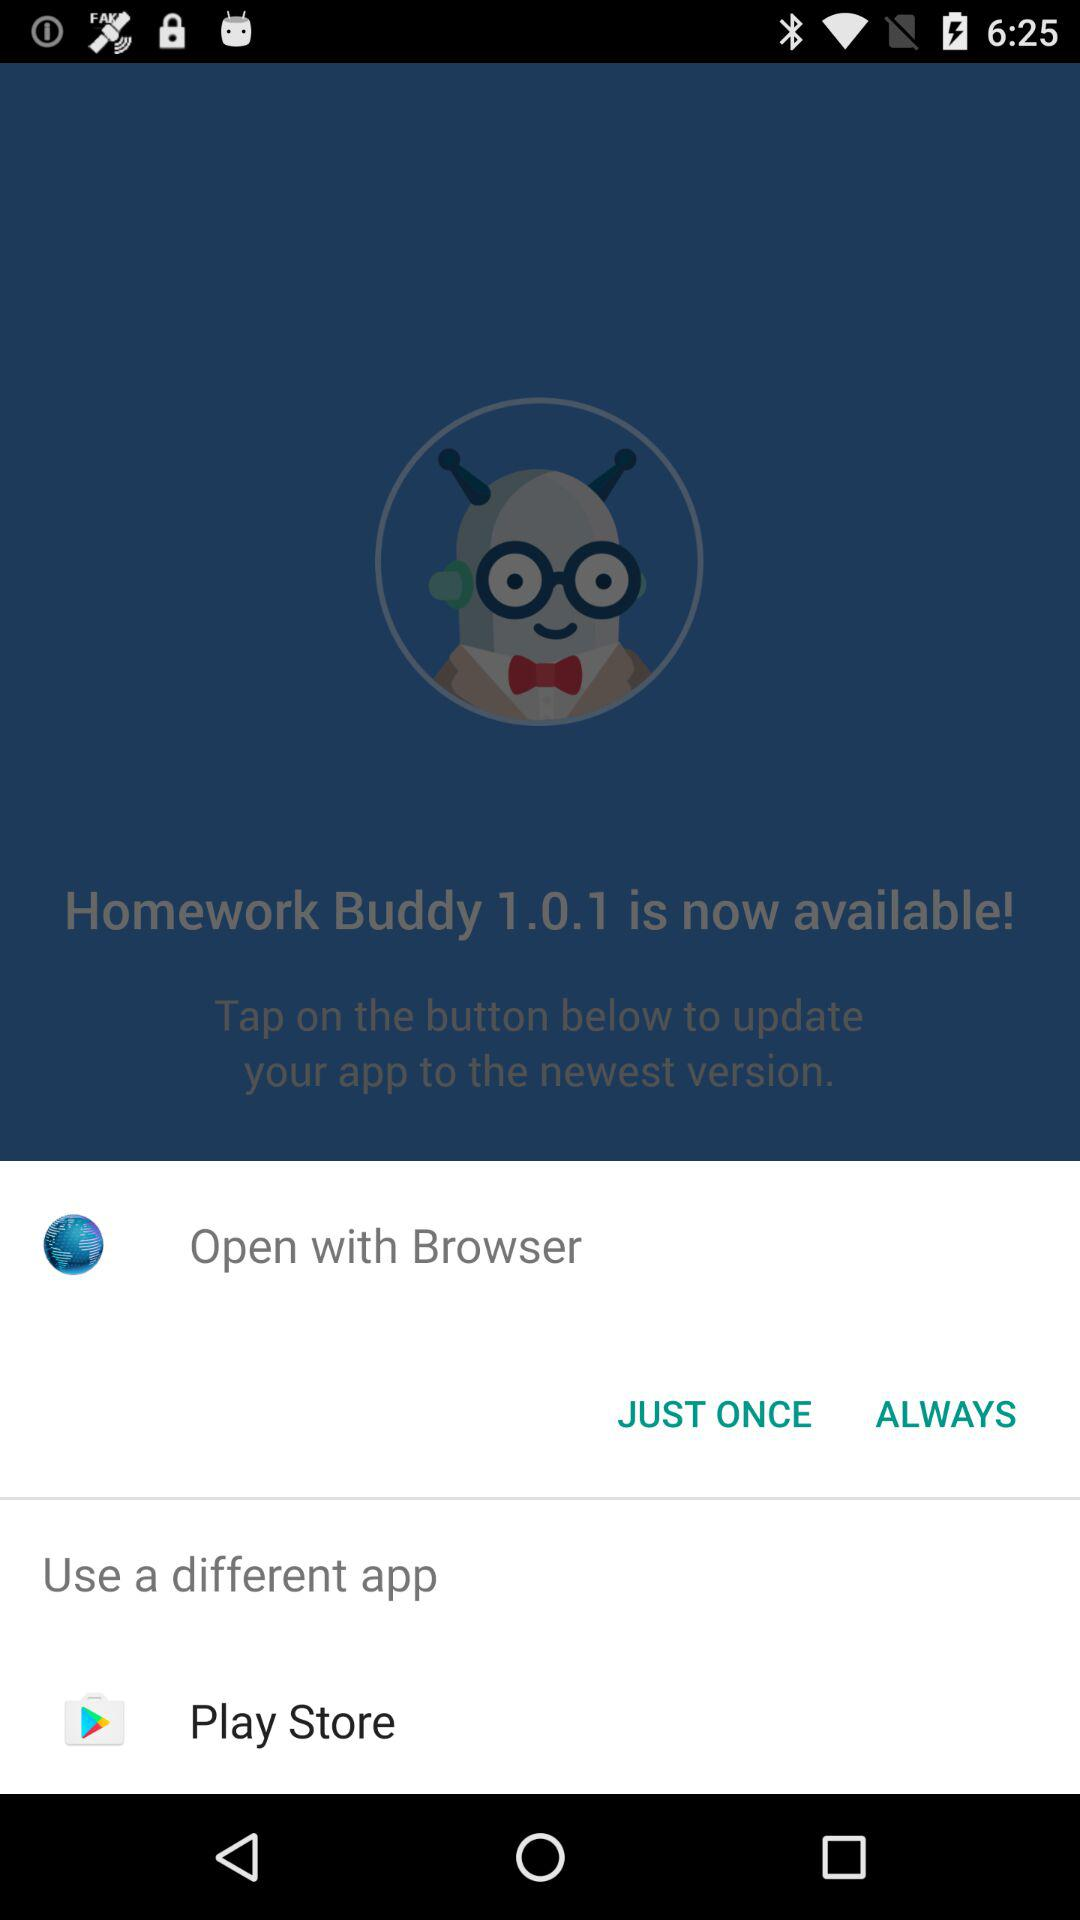What is the name of the application? The name of the application is "Homework Buddy". 